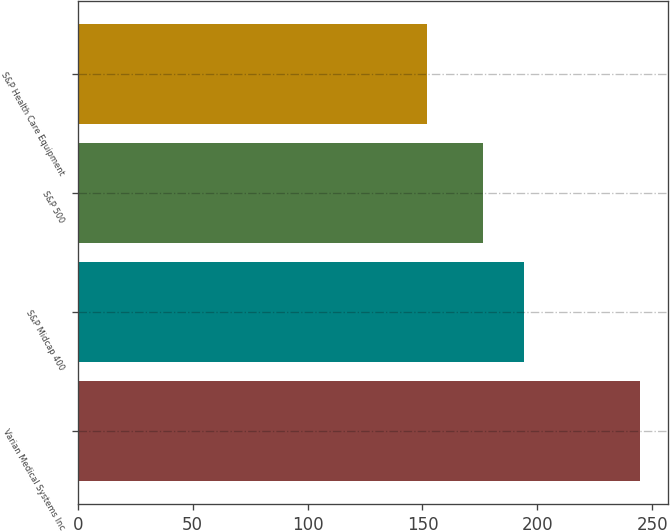Convert chart. <chart><loc_0><loc_0><loc_500><loc_500><bar_chart><fcel>Varian Medical Systems Inc<fcel>S&P Midcap 400<fcel>S&P 500<fcel>S&P Health Care Equipment<nl><fcel>244.46<fcel>194.05<fcel>176.17<fcel>152.06<nl></chart> 